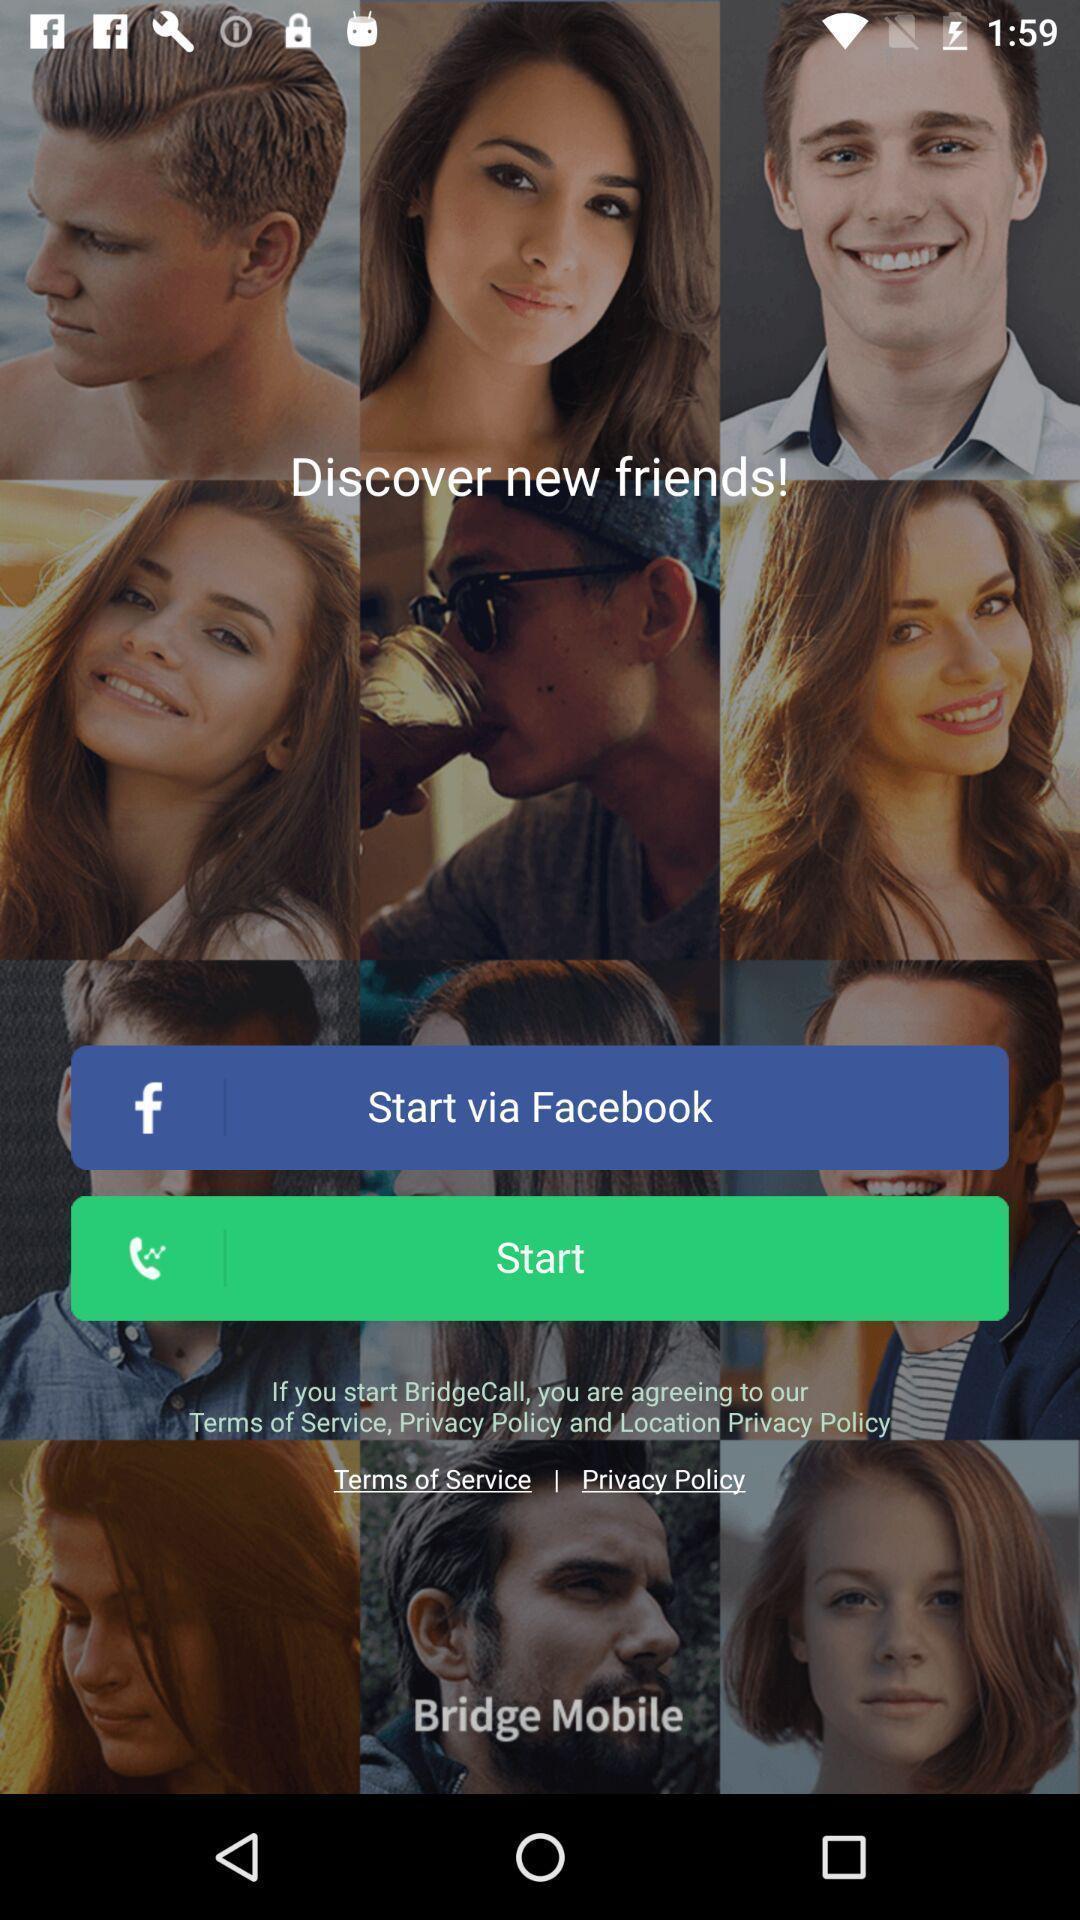What details can you identify in this image? Welcome page of a social media app. 